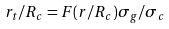Convert formula to latex. <formula><loc_0><loc_0><loc_500><loc_500>r _ { t } / R _ { c } = F ( r / R _ { c } ) \sigma _ { g } / \sigma _ { c }</formula> 